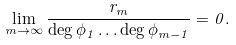<formula> <loc_0><loc_0><loc_500><loc_500>\lim _ { m \to \infty } \frac { r _ { m } } { \deg \phi _ { 1 } \dots \deg \phi _ { m - 1 } } = 0 .</formula> 